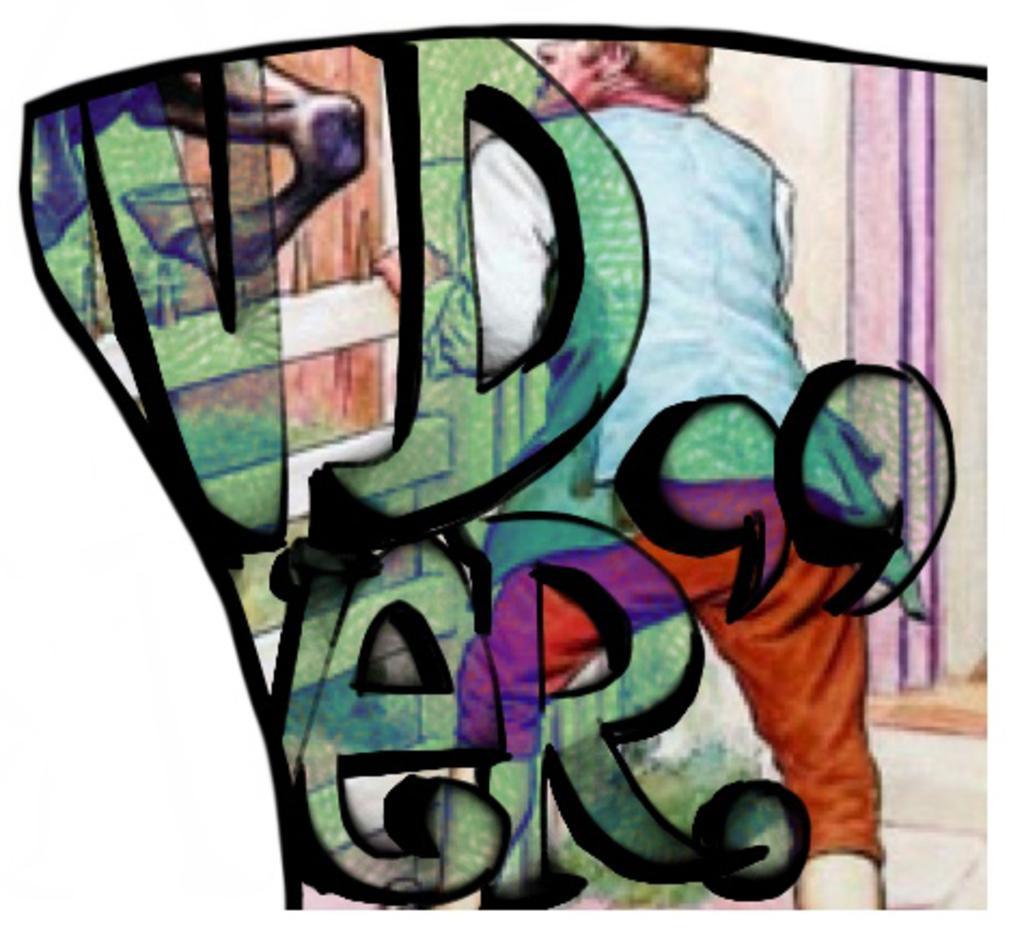Could you give a brief overview of what you see in this image? In this image I can see depiction picture where in the front I can see something is written and behind it I can see one person and legs of a horse. 